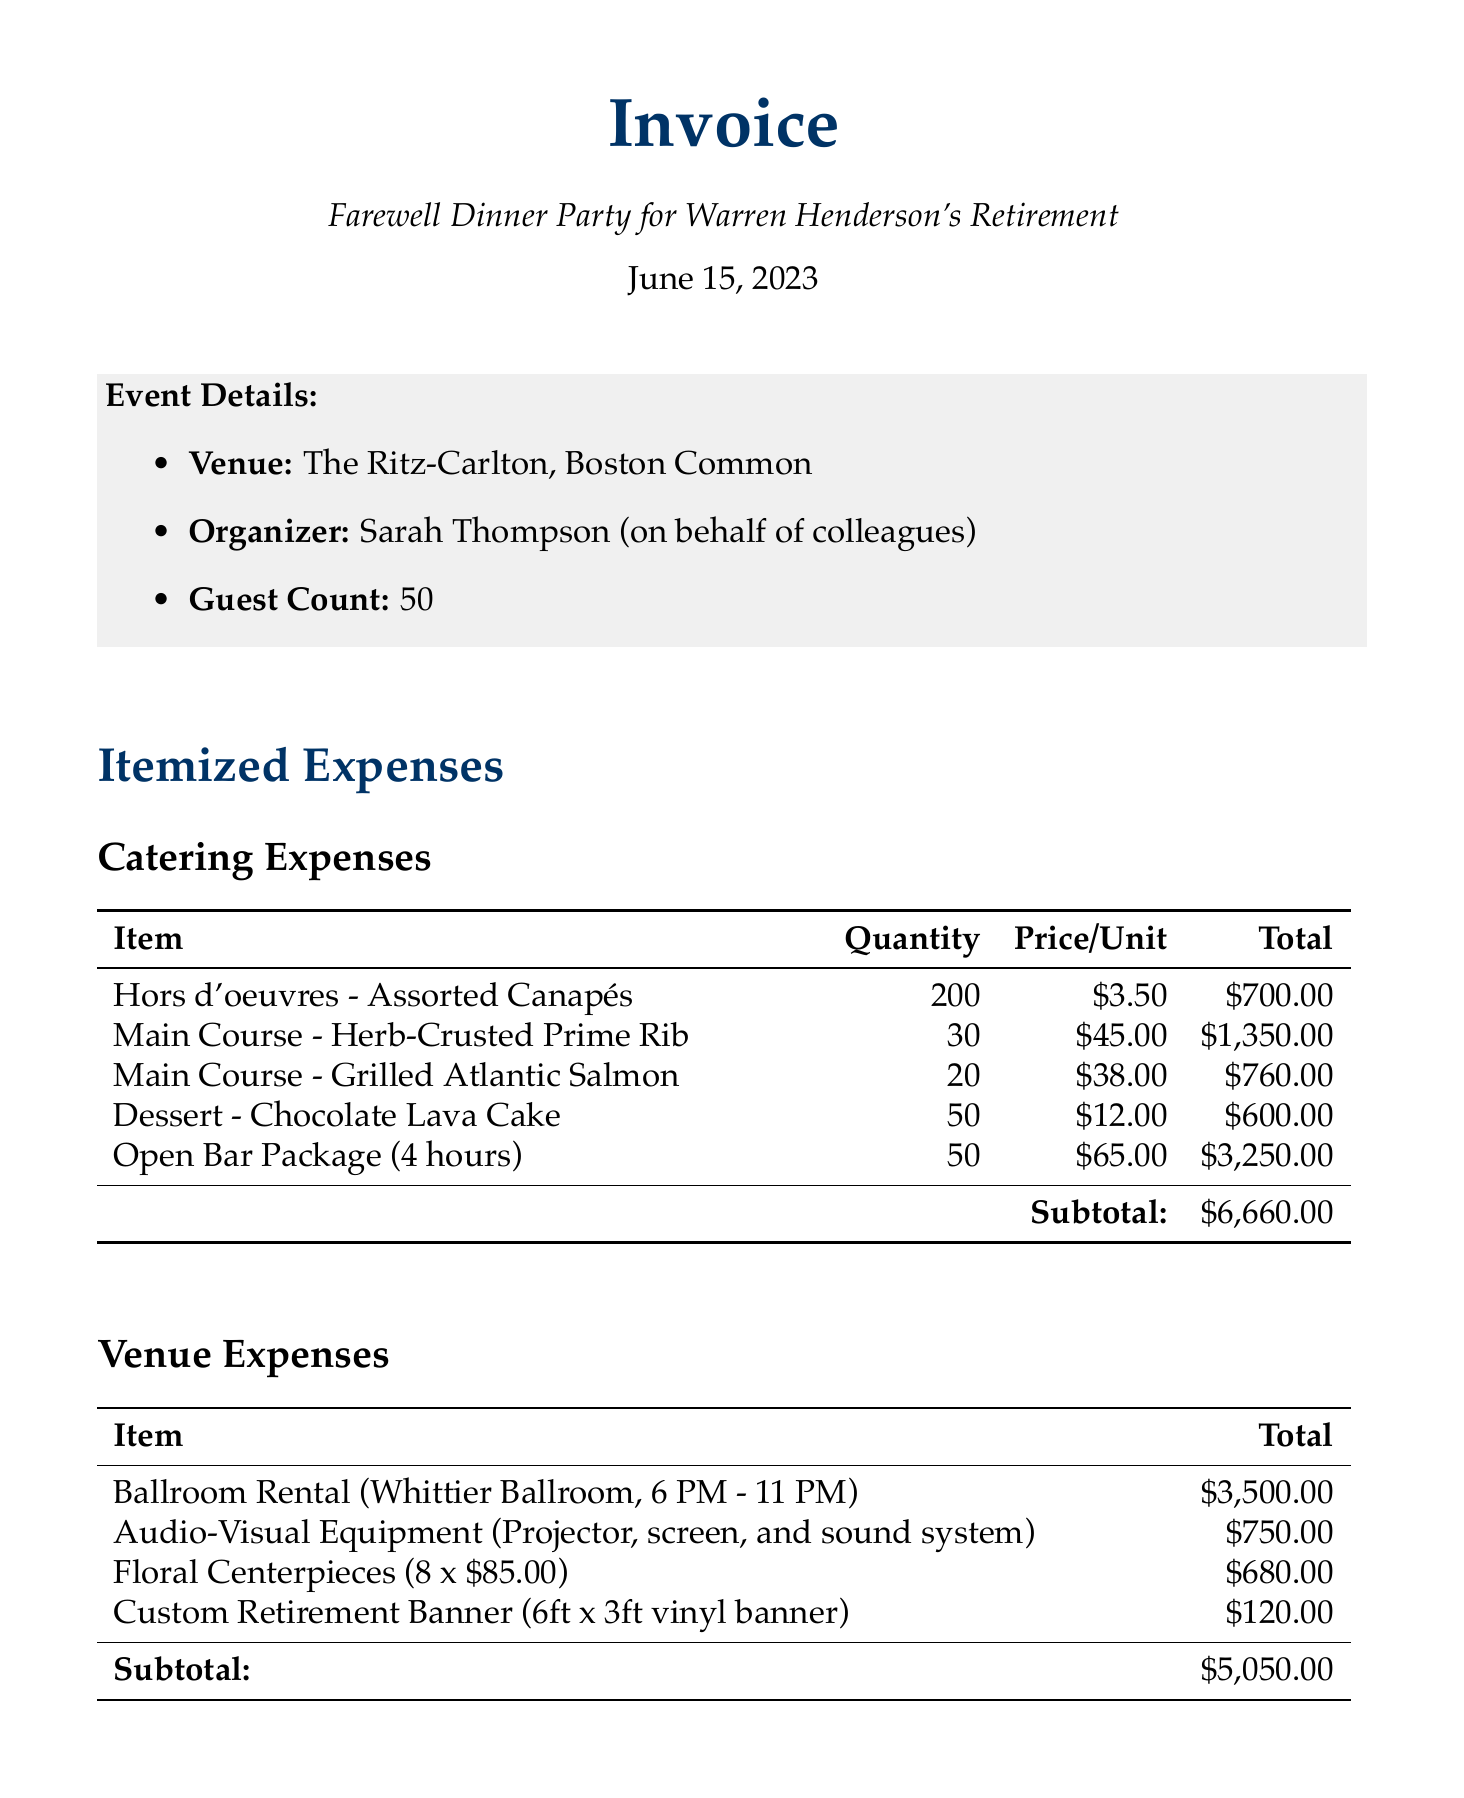What is the date of the farewell dinner party? The date is provided in the document as June 15, 2023.
Answer: June 15, 2023 What is the total cost of the catering expenses? The subtotal for catering expenses is clearly stated in the document.
Answer: $6,660.00 Who organized the farewell dinner party? The organizer's name is mentioned in the event details section of the document.
Answer: Sarah Thompson How many guests were expected at the dinner party? The guest count is specified in the document.
Answer: 50 What is the total invoice amount? The total amount for the invoice is summarized at the end of the expenses section.
Answer: $14,360.00 What type of band performed at the event? The document specifies the type of band in the additional expenses section.
Answer: Live Jazz Band What item had the highest catering cost? To find this, one must look at the catering expenses and determine the highest total.
Answer: Open Bar Package (4 hours) How many floral centerpieces were included? The quantity of floral centerpieces is detailed in the venue expenses section.
Answer: 8 What was included in the audio-visual equipment? The description of the audio-visual equipment lists its components in the venue expenses section.
Answer: Projector, screen, and sound system 